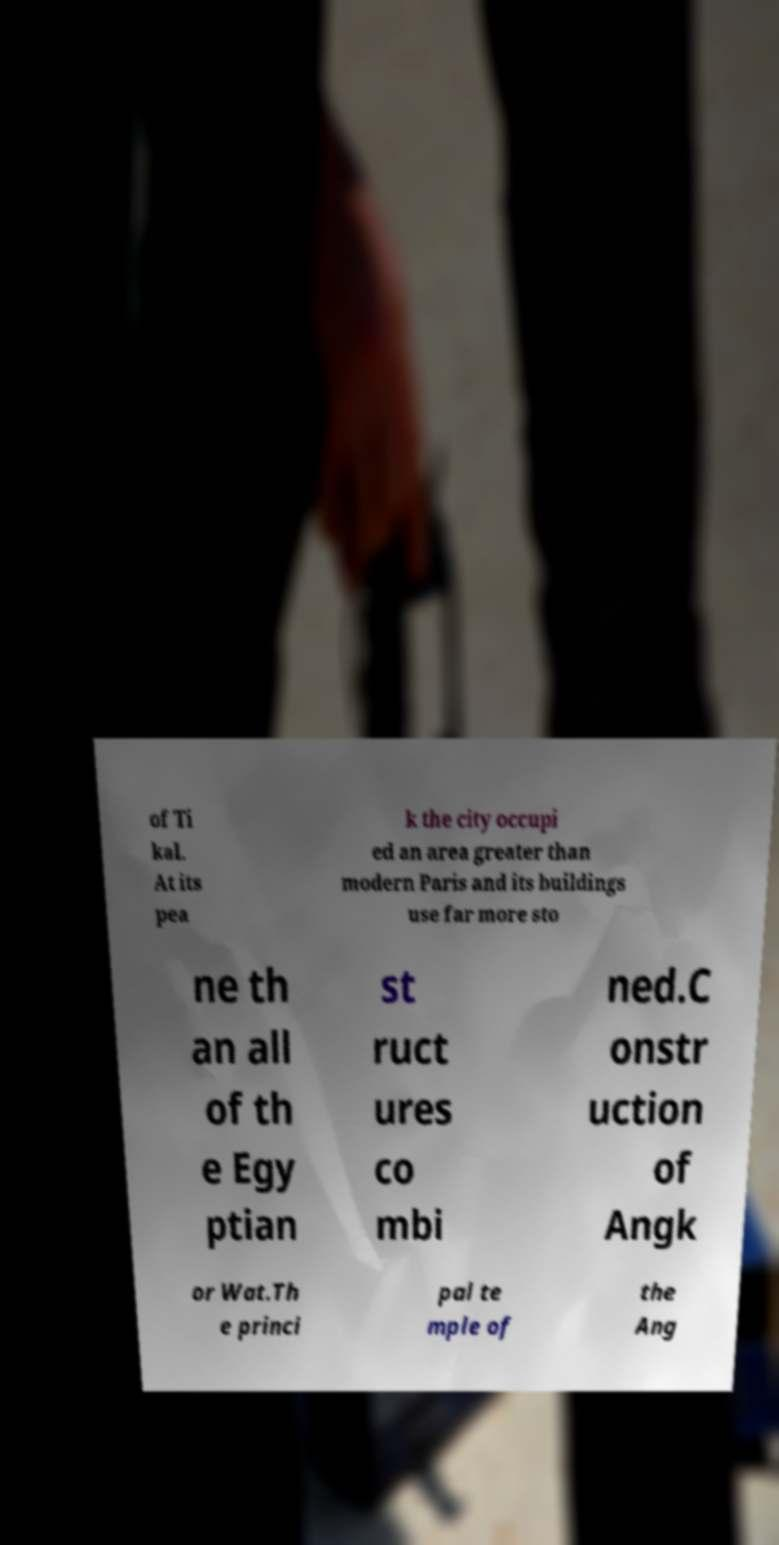For documentation purposes, I need the text within this image transcribed. Could you provide that? of Ti kal. At its pea k the city occupi ed an area greater than modern Paris and its buildings use far more sto ne th an all of th e Egy ptian st ruct ures co mbi ned.C onstr uction of Angk or Wat.Th e princi pal te mple of the Ang 